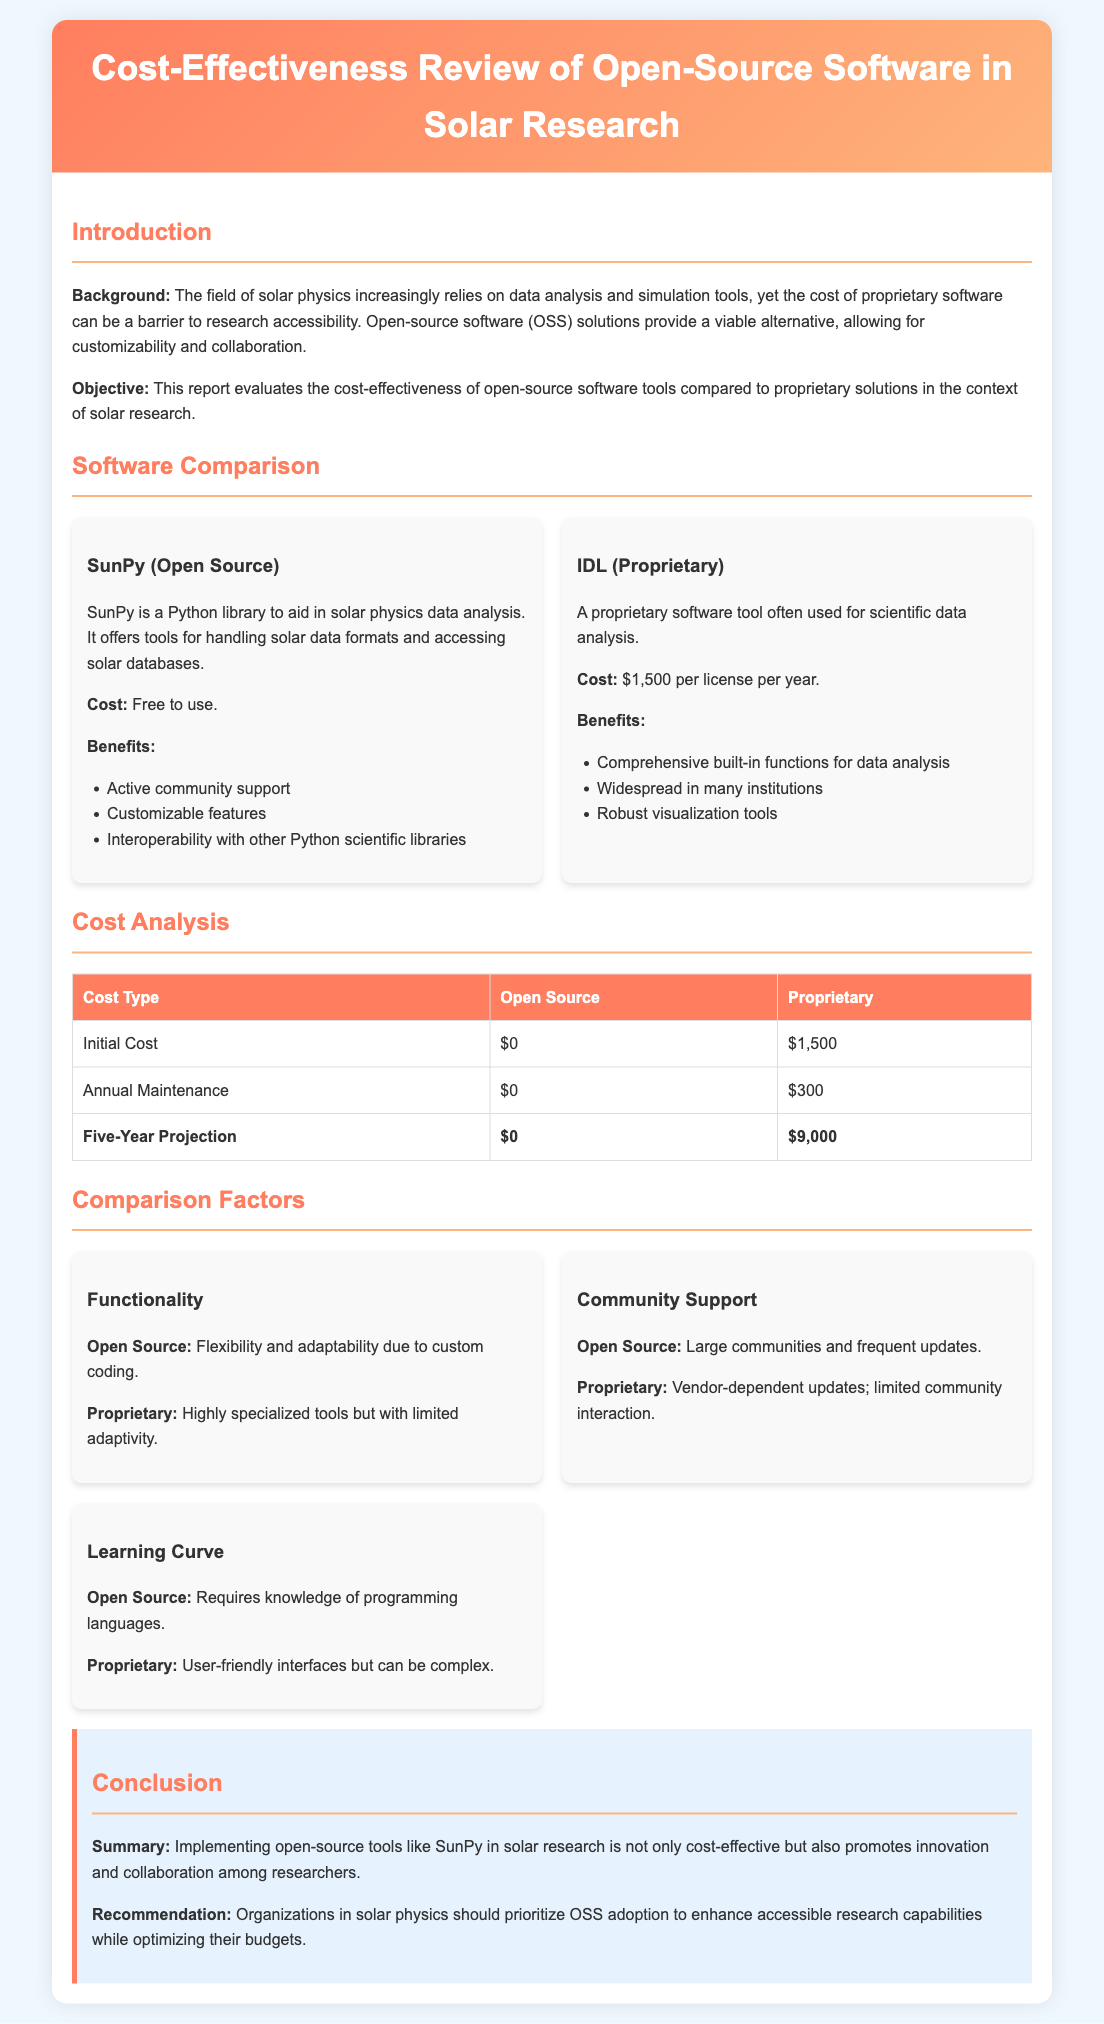What is the cost of using SunPy? SunPy is free to use, making it a cost-effective solution for researchers.
Answer: Free to use What is the annual maintenance cost for IDL? The document states that the annual maintenance for IDL is $300 per year.
Answer: $300 What is the five-year projection cost for proprietary software? The five-year projection for proprietary software costs $9,000, which reflects high expenses over time.
Answer: $9,000 What benefit does SunPy offer regarding community support? SunPy has large communities and frequent updates, which enhances its usability and support.
Answer: Large communities and frequent updates Which software provides better flexibility and adaptability? Open source software like SunPy allows for greater flexibility and adaptability compared to proprietary software.
Answer: Open Source What is the recommendation provided in the conclusion? The report recommends prioritizing open-source software adoption in solar physics for better research capabilities.
Answer: OSS adoption What type of learning curve is associated with open-source software? Open-source software often requires knowledge of programming languages, making learning more complex.
Answer: Knowledge of programming languages What is the main objective of the report? The objective is to evaluate the cost-effectiveness of open-source software tools in solar research compared to proprietary solutions.
Answer: Evaluate cost-effectiveness 